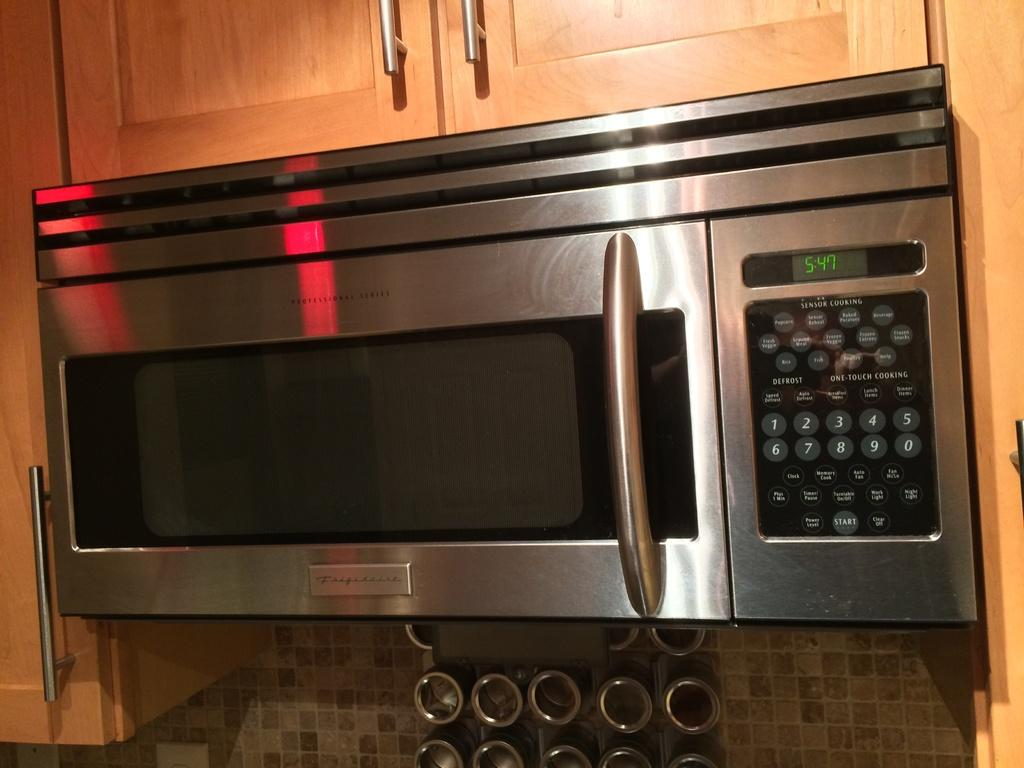<image>
Provide a brief description of the given image. 5:47 reads the digital display of this microwave oven. 